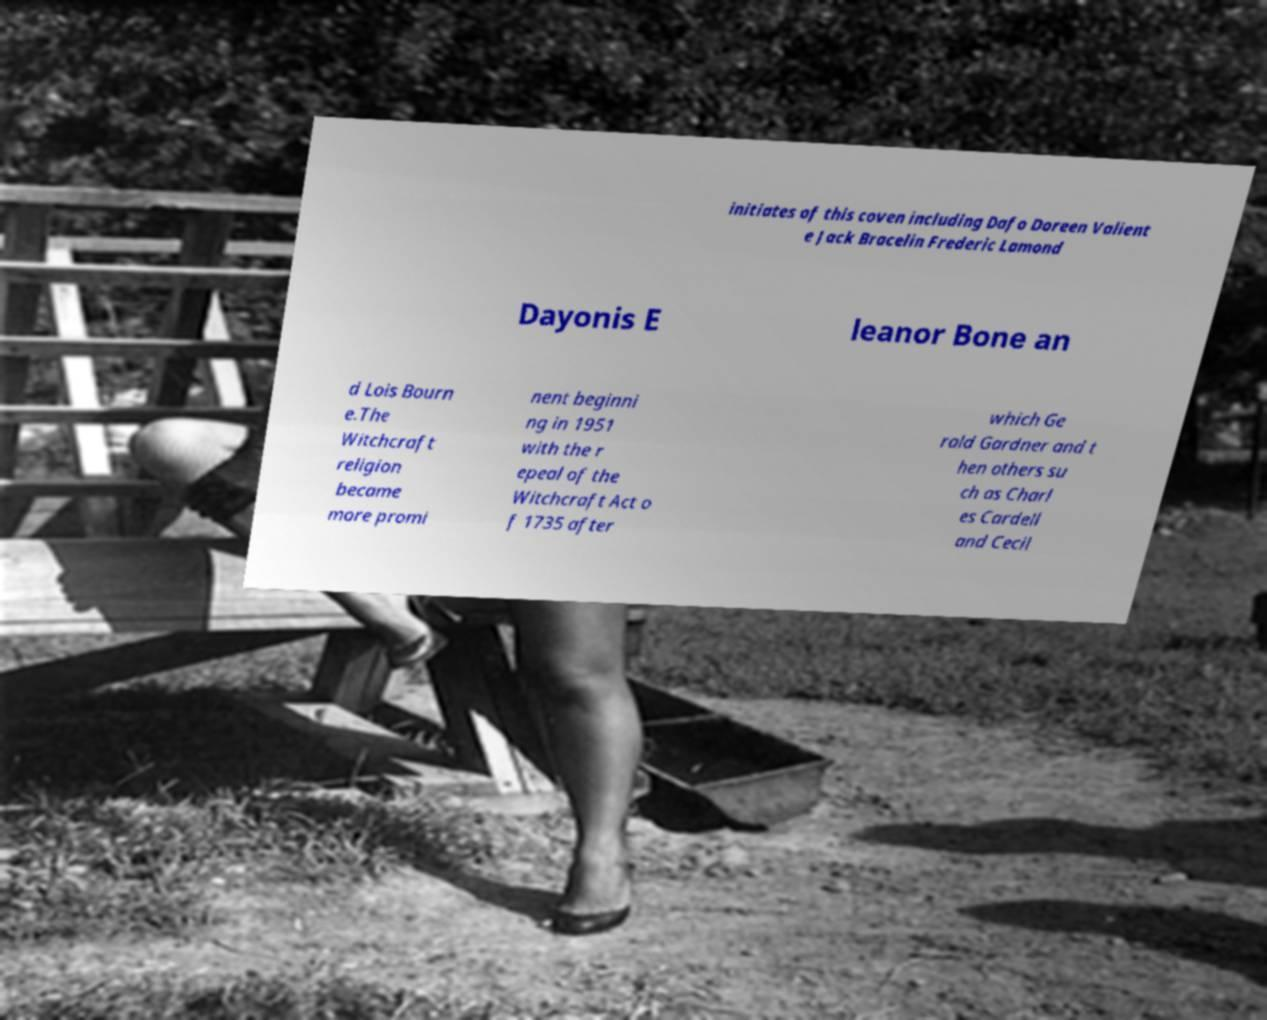There's text embedded in this image that I need extracted. Can you transcribe it verbatim? initiates of this coven including Dafo Doreen Valient e Jack Bracelin Frederic Lamond Dayonis E leanor Bone an d Lois Bourn e.The Witchcraft religion became more promi nent beginni ng in 1951 with the r epeal of the Witchcraft Act o f 1735 after which Ge rald Gardner and t hen others su ch as Charl es Cardell and Cecil 